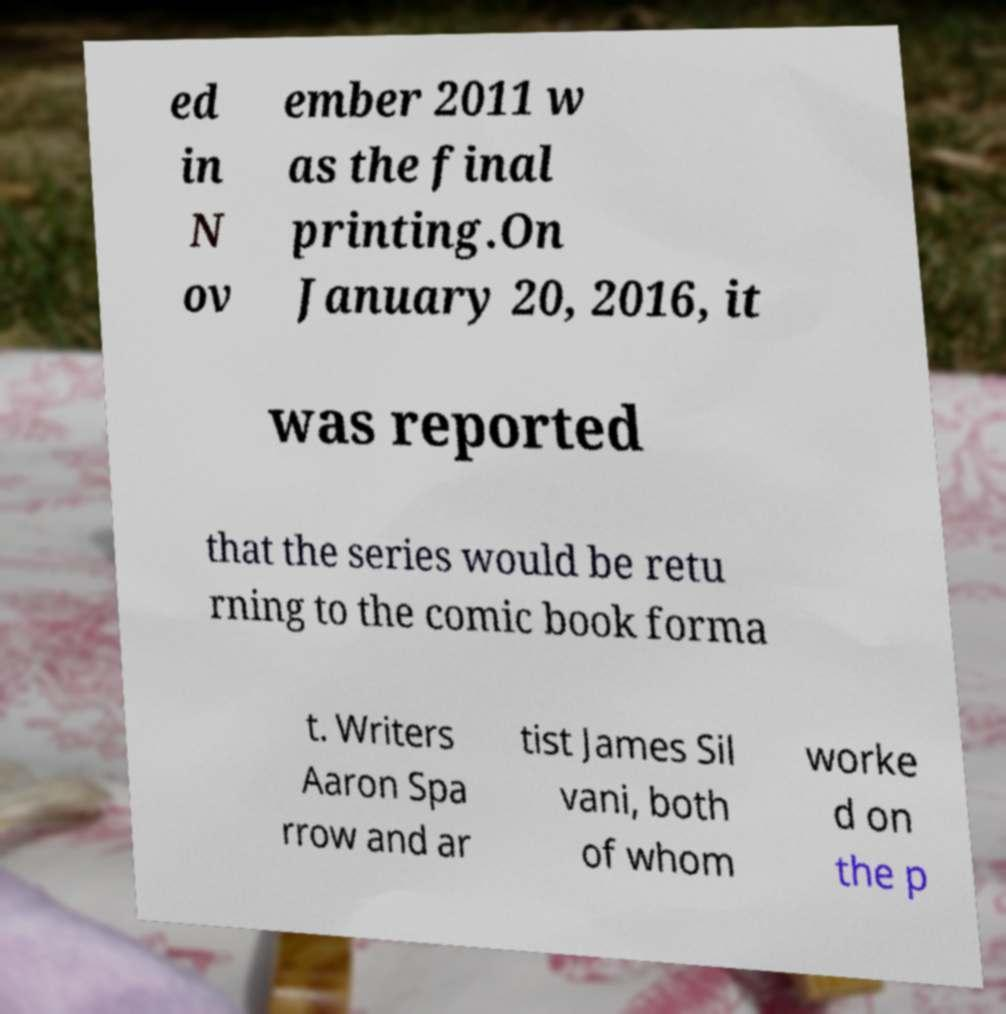Please read and relay the text visible in this image. What does it say? ed in N ov ember 2011 w as the final printing.On January 20, 2016, it was reported that the series would be retu rning to the comic book forma t. Writers Aaron Spa rrow and ar tist James Sil vani, both of whom worke d on the p 